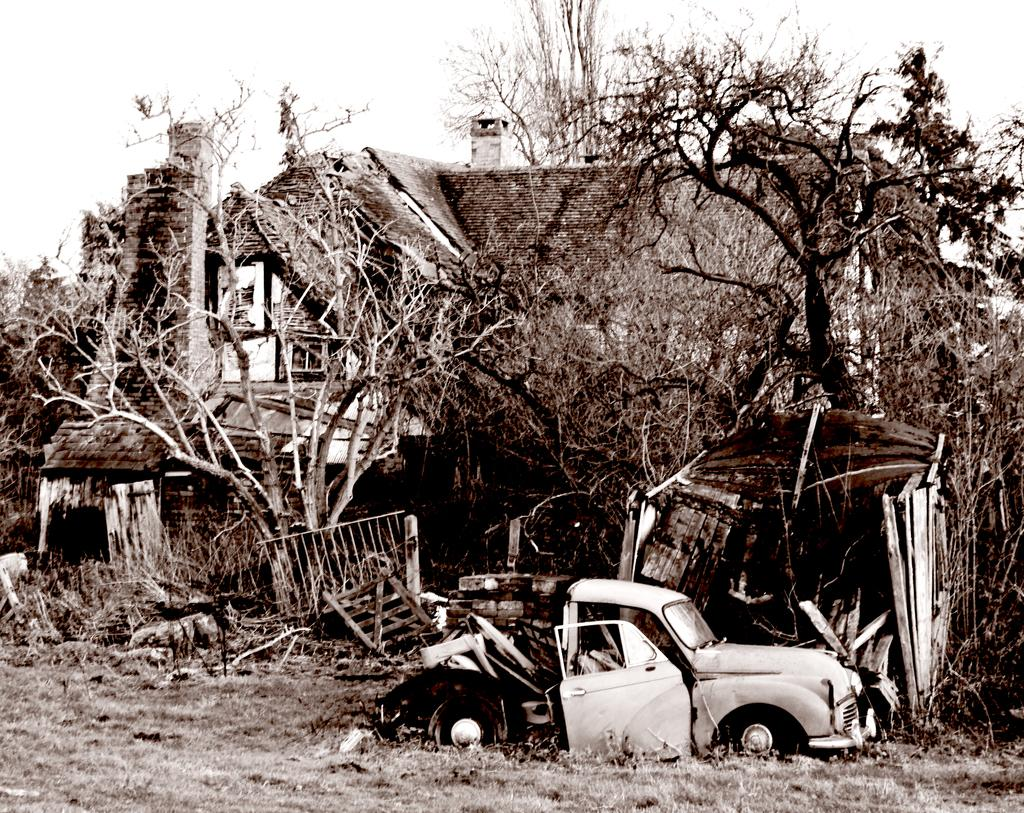What is the condition of the car in the image? The car in the image is broken. What type of objects can be seen in the image besides the car? There are wooden objects and dried trees in the image. What can be seen in the background of the image? There is a house with a chimney in the background of the image. How many girls are coughing in the image? There are no girls or coughing present in the image. What season is depicted in the image? The provided facts do not mention any season or weather-related details, so it cannot be determined from the image. 